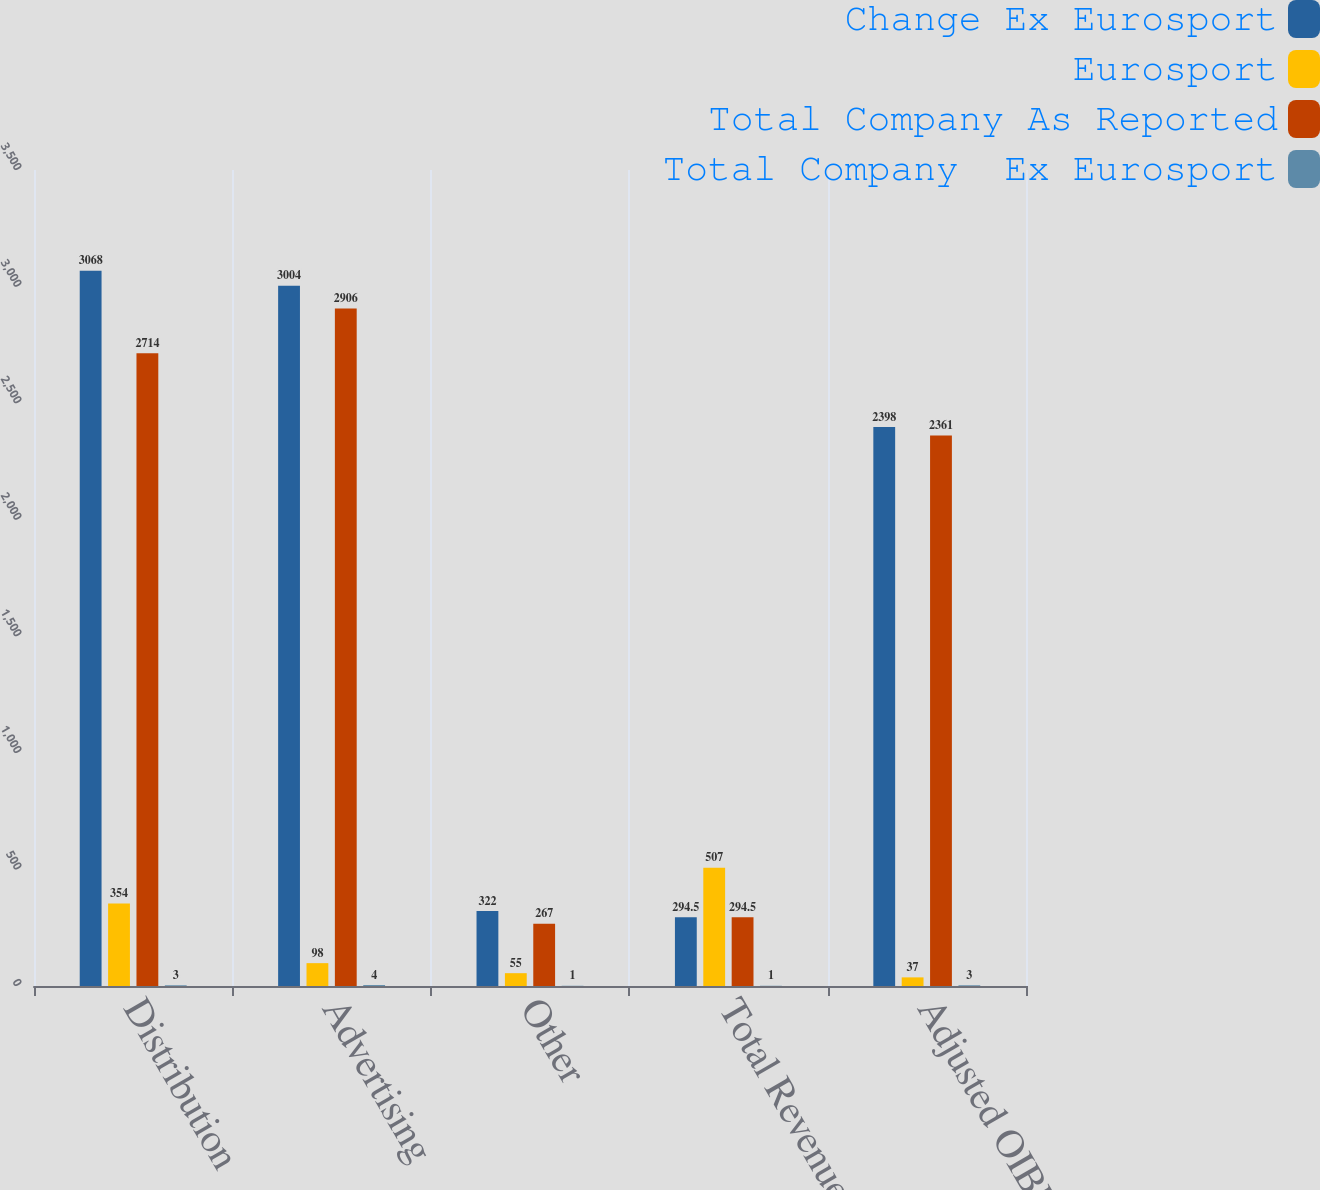Convert chart. <chart><loc_0><loc_0><loc_500><loc_500><stacked_bar_chart><ecel><fcel>Distribution<fcel>Advertising<fcel>Other<fcel>Total Revenues<fcel>Adjusted OIBDA<nl><fcel>Change Ex Eurosport<fcel>3068<fcel>3004<fcel>322<fcel>294.5<fcel>2398<nl><fcel>Eurosport<fcel>354<fcel>98<fcel>55<fcel>507<fcel>37<nl><fcel>Total Company As Reported<fcel>2714<fcel>2906<fcel>267<fcel>294.5<fcel>2361<nl><fcel>Total Company  Ex Eurosport<fcel>3<fcel>4<fcel>1<fcel>1<fcel>3<nl></chart> 